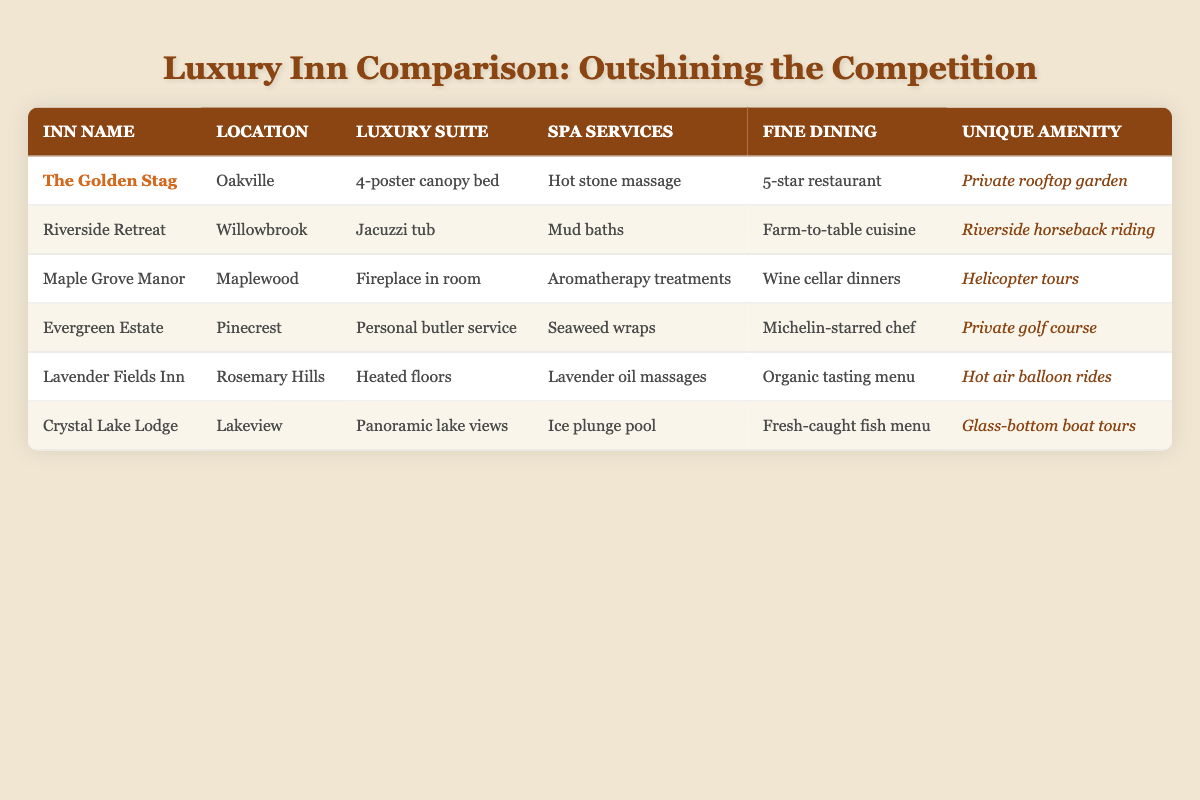What unique amenity does Evergreen Estate offer? The table shows that Evergreen Estate has a 'Private golf course' listed as its unique amenity.
Answer: Private golf course Which inn has the highest luxury suite feature? The luxury suites of the inns vary in features, but Evergreen Estate stands out with 'Personal butler service,' which is a particularly high-end amenity compared to others.
Answer: Personal butler service Is there any inn that offers both spa services and fine dining? By checking the table, all inns listed provide spa services and fine dining. Thus, the answer is yes, all of them offer both.
Answer: Yes Which inn offers a Jacuzzi tub as its luxury suite feature? Upon examining the table, Rivers Retreat is the only inn that specifically lists 'Jacuzzi tub' as its luxury suite feature.
Answer: Riverside Retreat Which inn has the most unique amenities? The table needs to be checked for 'Unique Amenity' for each inn, and among them, all inns have unique amenities, but each is distinct. The comparison does not yield a single winner, as they cater to different preferences.
Answer: None What is the combined total of unique amenities for all inns? All inns listed provide unique amenities, so by counting them: there are six inns, each with one unique amenity. Hence, there are a total of 6 unique amenities.
Answer: 6 Which inn has both organic dining and a nature-related unique amenity? From the table, we find that Lavender Fields Inn has an 'Organic tasting menu' under fine dining and 'Hot air balloon rides' for the unique amenity, which relates to nature.
Answer: Lavender Fields Inn Does Maple Grove Manor offer a spa service? In referring to the table, it is clear that Maple Grove Manor provides 'Aromatherapy treatments' as its spa service. Therefore, it does offer spa services.
Answer: Yes Which inn features a hot stone massage and what is its unique amenity? The table indicates that The Golden Stag provides a 'Hot stone massage' under spa services, and its unique amenity is a 'Private rooftop garden.'
Answer: Private rooftop garden 